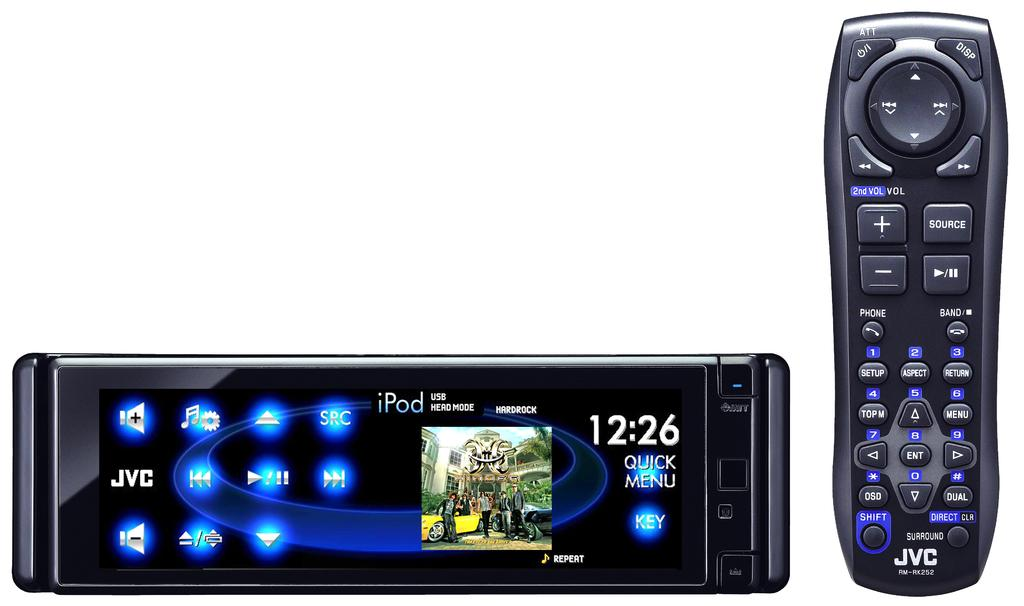<image>
Present a compact description of the photo's key features. JVC screen can connect to your iPod and be used with a remote. 